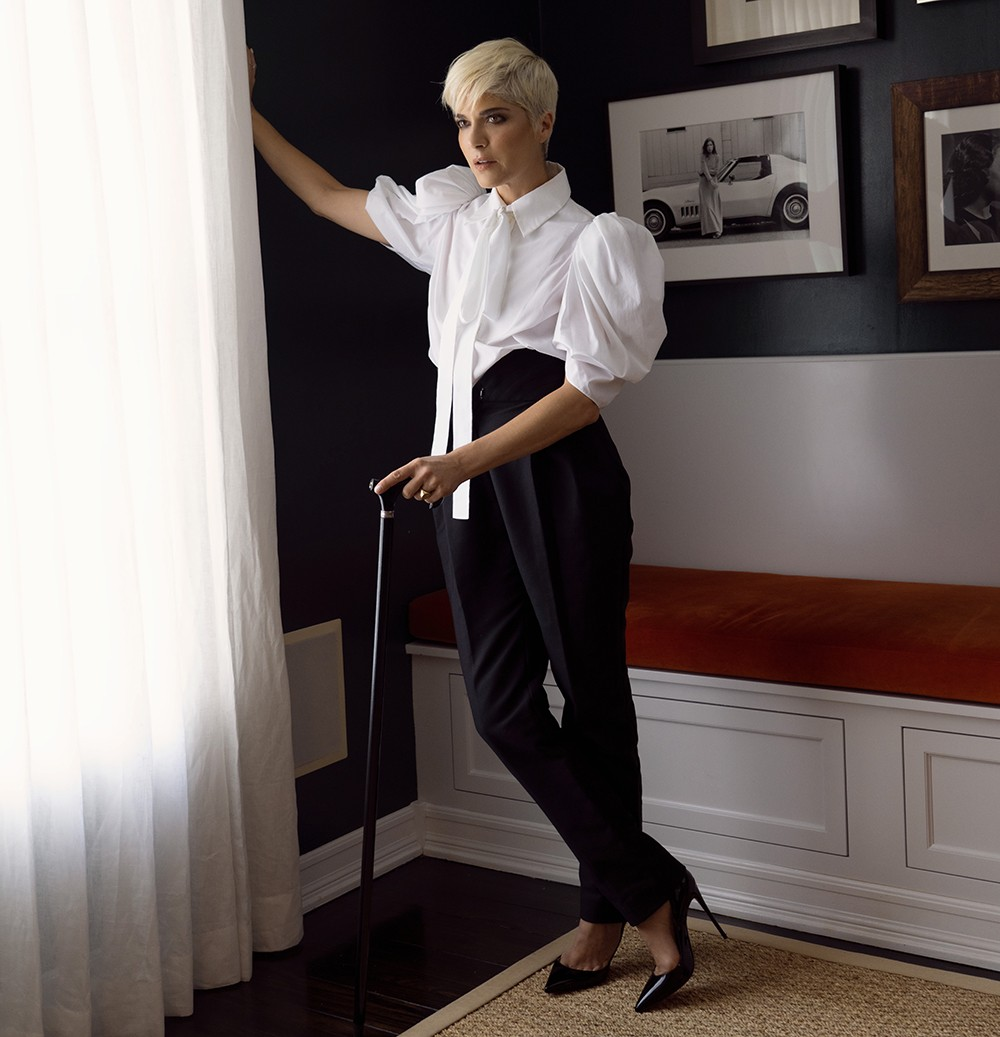What is this photo about? In this image, a notable figure is captured in a moment of quiet introspection. She stands elegantly in a room with stark black walls, which contrast sharply with the soft white curtain beside her. Her chic black and white outfit mirrors the room’s monochrome color palette, while her short blonde hair frames her face, giving prominence to her serious expression as she gazes off to the side.

In her hand, she holds a cane, symbolizing strength and resilience. Behind her, a framed photo of a car on the wall adds an intriguing element to the composition. In the foreground, there’s a bench with an inviting orange cushion, providing a striking pop of color amid the otherwise muted setting. This image not only captures the essence of the personality depicted but also offers a glimpse into her character and spirit. 